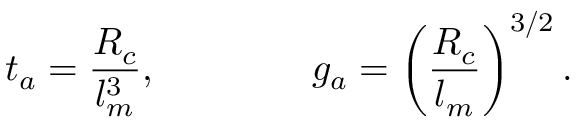Convert formula to latex. <formula><loc_0><loc_0><loc_500><loc_500>t _ { a } = { \frac { R _ { c } } { l _ { m } ^ { 3 } } } , \quad g _ { a } = \left ( { \frac { R _ { c } } { l _ { m } } } \right ) ^ { 3 / 2 } .</formula> 